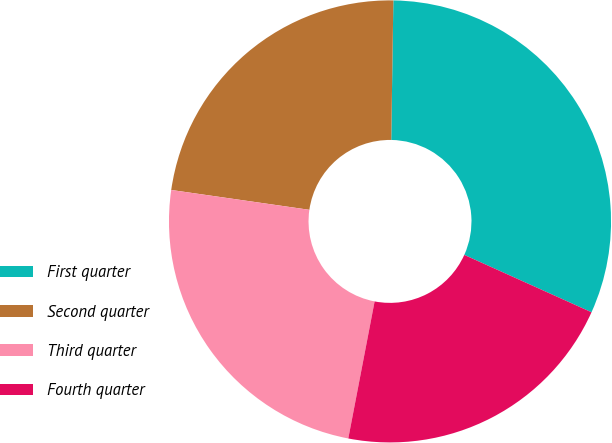Convert chart. <chart><loc_0><loc_0><loc_500><loc_500><pie_chart><fcel>First quarter<fcel>Second quarter<fcel>Third quarter<fcel>Fourth quarter<nl><fcel>31.5%<fcel>22.97%<fcel>24.25%<fcel>21.28%<nl></chart> 